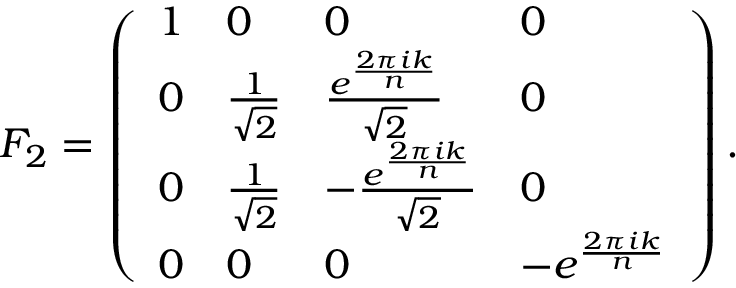<formula> <loc_0><loc_0><loc_500><loc_500>F _ { 2 } = \left ( \begin{array} { l l l l } { 1 } & { 0 } & { 0 } & { 0 } \\ { 0 } & { \frac { 1 } { \sqrt { 2 } } } & { \frac { e ^ { \frac { 2 \pi i k } { n } } } { \sqrt { 2 } } } & { 0 } \\ { 0 } & { \frac { 1 } { \sqrt { 2 } } } & { - \frac { e ^ { \frac { 2 \pi i k } { n } } } { \sqrt { 2 } } } & { 0 } \\ { 0 } & { 0 } & { 0 } & { - e ^ { \frac { 2 \pi i k } { n } } } \end{array} \right ) .</formula> 